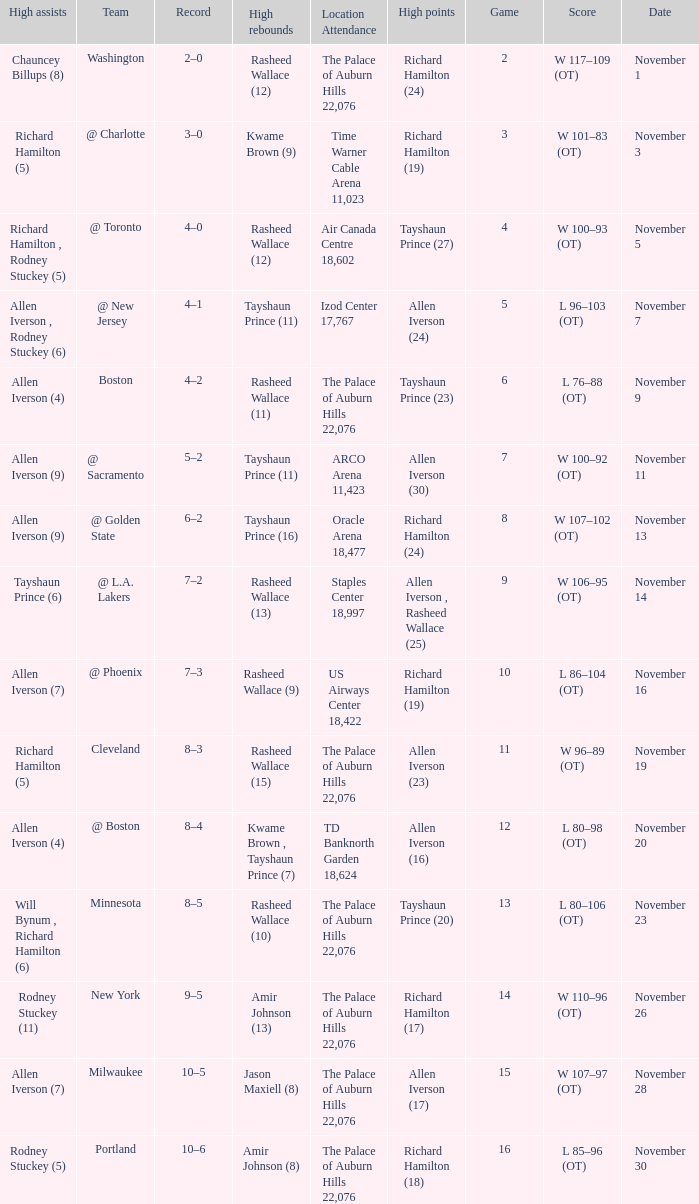What is High Points, when Game is "5"? Allen Iverson (24). 